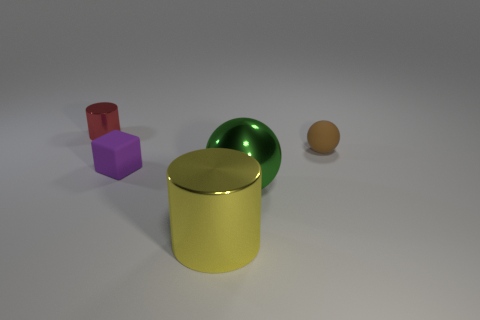How many things are either cylinders left of the tiny block or shiny cylinders in front of the purple block?
Give a very brief answer. 2. Is the number of small red shiny objects less than the number of small cyan metallic cylinders?
Provide a short and direct response. No. There is a purple thing; does it have the same size as the metallic thing that is left of the big metallic cylinder?
Make the answer very short. Yes. How many rubber things are either tiny purple cubes or cylinders?
Keep it short and to the point. 1. Is the number of small red metallic things greater than the number of big red cylinders?
Provide a succinct answer. Yes. There is a small matte object right of the metallic cylinder that is in front of the purple block; what is its shape?
Give a very brief answer. Sphere. There is a cylinder behind the tiny matte block that is on the left side of the metallic ball; is there a tiny ball that is behind it?
Your answer should be compact. No. There is a metallic cylinder that is the same size as the green ball; what color is it?
Make the answer very short. Yellow. The metal thing that is on the right side of the small red metal cylinder and behind the big cylinder has what shape?
Keep it short and to the point. Sphere. What size is the rubber object that is in front of the small rubber thing that is to the right of the purple matte block?
Provide a succinct answer. Small. 